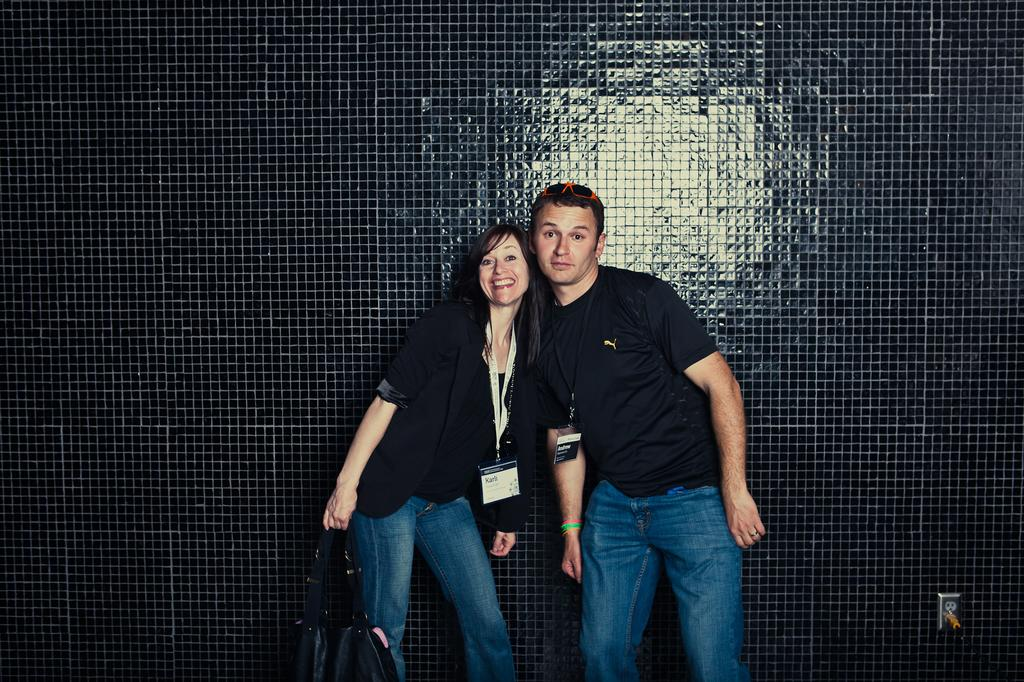How many people are in the image? There are two people in the image, a woman and a man. What are the people in the image wearing? The woman is wearing a black dress, and the man is wearing a blue dress. What is the woman holding in the image? The woman is holding a bag. What color is the wall in the background of the image? The wall in the background of the image is black. What type of game are the people playing in the image? There is no game being played in the image; it simply shows a woman and a man standing together. What kind of battle is depicted in the image? There is no battle depicted in the image; it features a woman and a man standing together with no signs of conflict. 